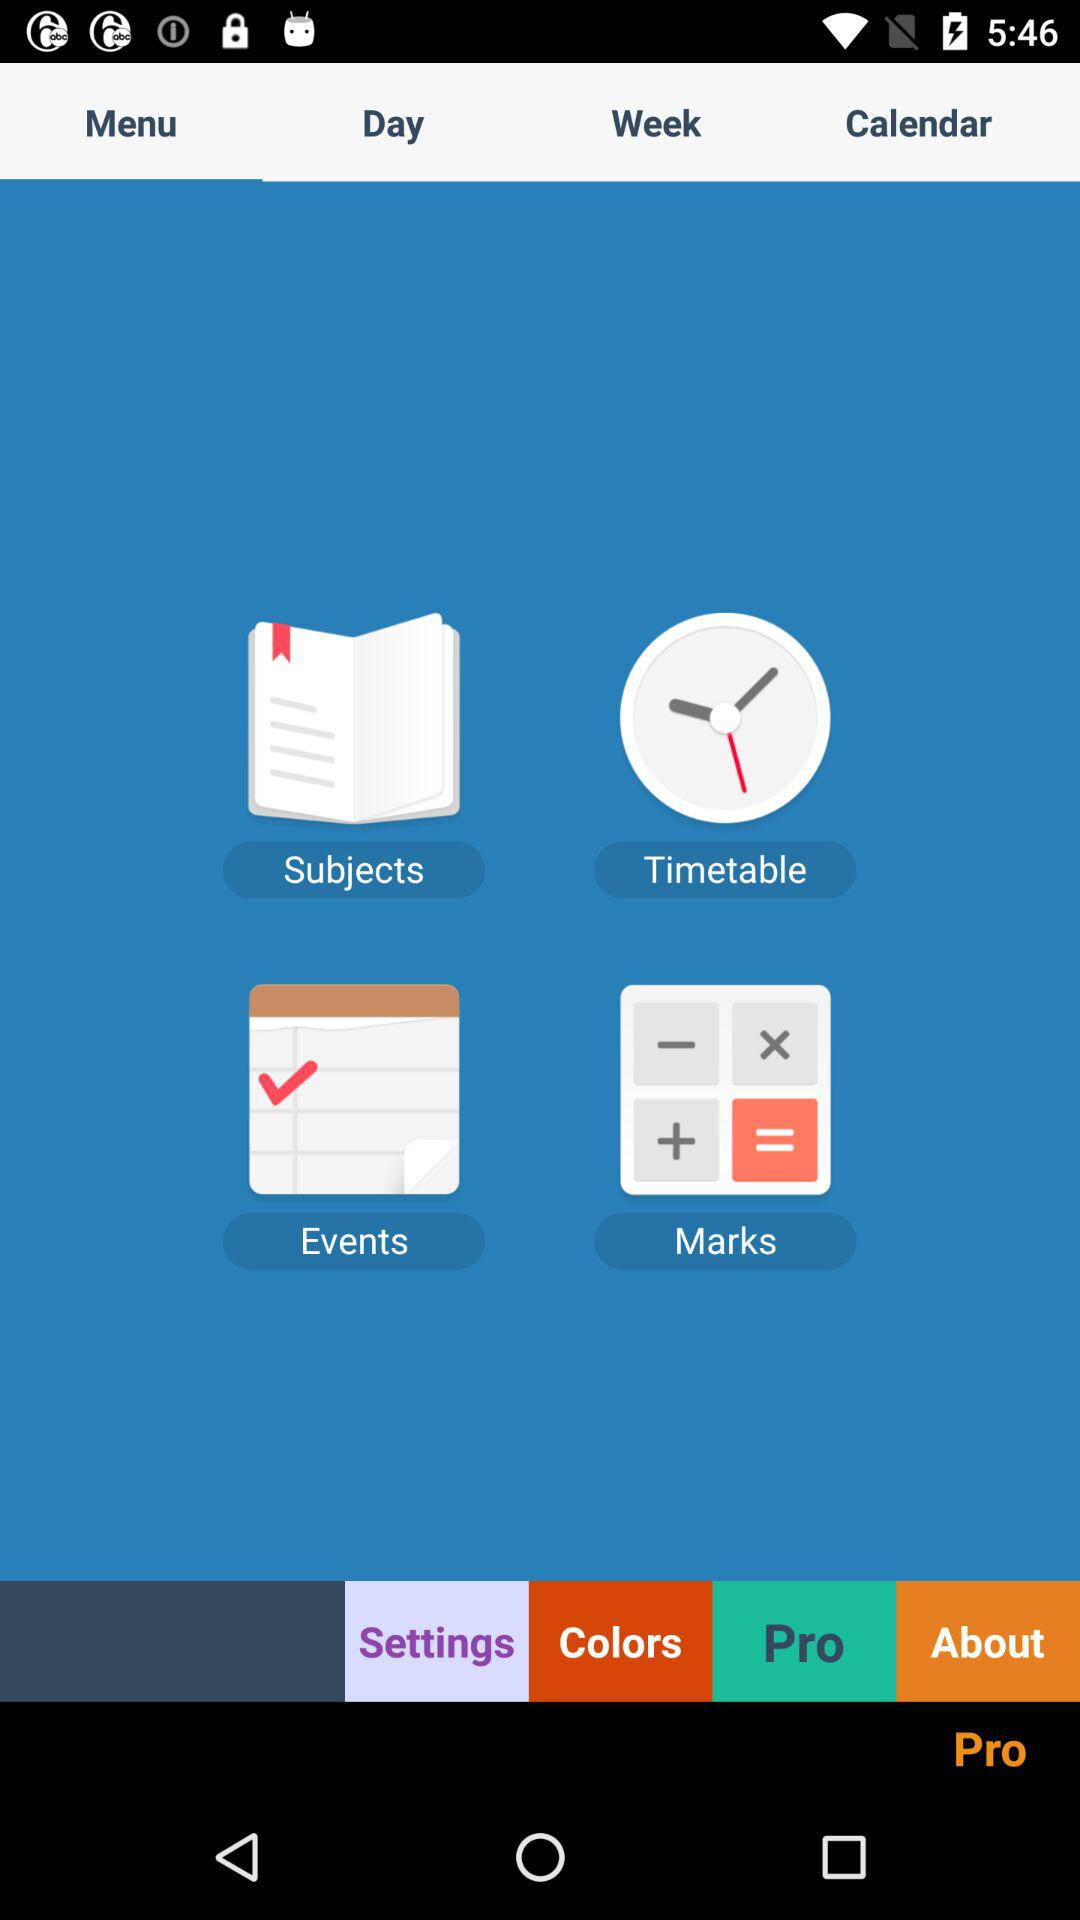Which tab is selected? The selected tab is "Menu". 